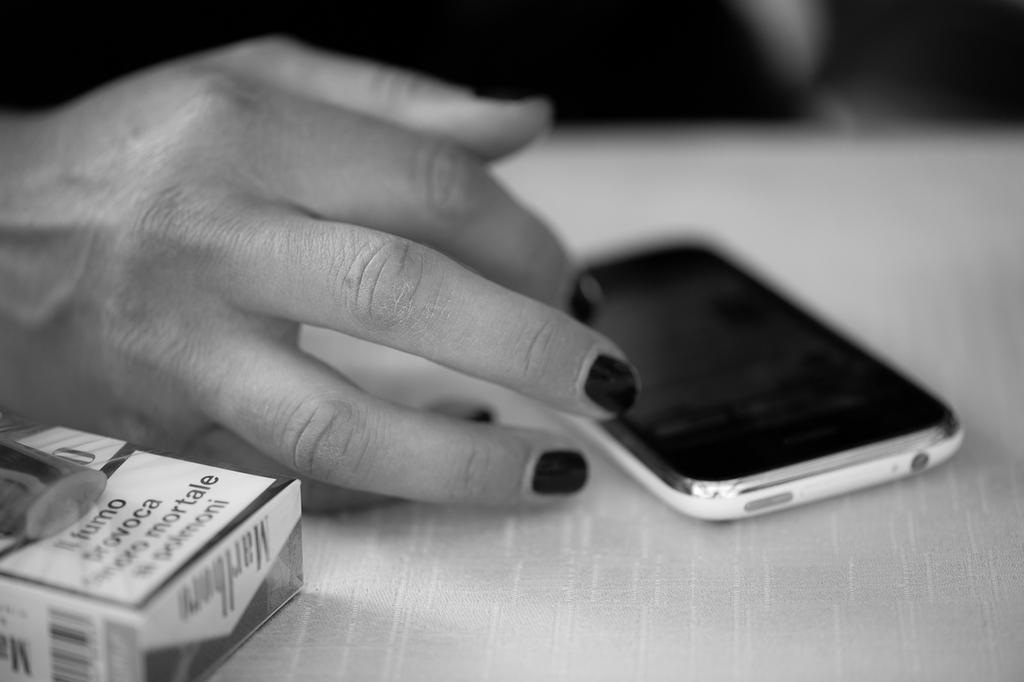What cigarettes are on the table?
Your response must be concise. Marlboro. What brand are the cigarettes?
Give a very brief answer. Marlboro. 